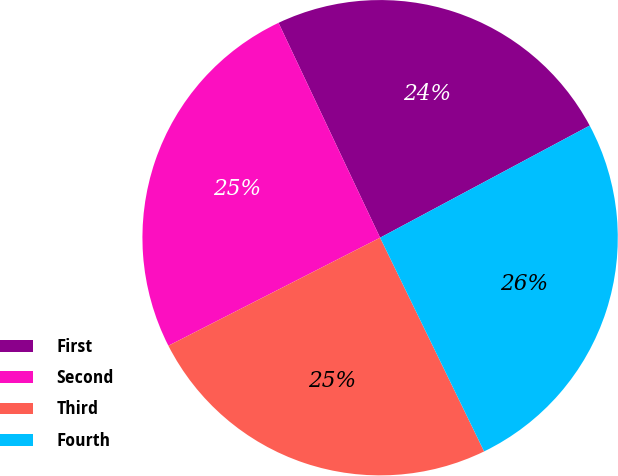Convert chart to OTSL. <chart><loc_0><loc_0><loc_500><loc_500><pie_chart><fcel>First<fcel>Second<fcel>Third<fcel>Fourth<nl><fcel>24.21%<fcel>25.48%<fcel>24.7%<fcel>25.61%<nl></chart> 